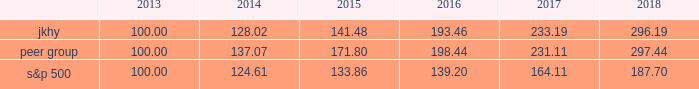14 2018 annual report performance graph the following chart presents a comparison for the five-year period ended june 30 , 2018 , of the market performance of the company 2019s common stock with the s&p 500 index and an index of peer companies selected by the company .
Historic stock price performance is not necessarily indicative of future stock price performance .
Comparison of 5 year cumulative total return among jack henry & associates , inc. , the s&p 500 index , and a peer group the following information depicts a line graph with the following values: .
This comparison assumes $ 100 was invested on june 30 , 2013 , and assumes reinvestments of dividends .
Total returns are calculated according to market capitalization of peer group members at the beginning of each period .
Peer companies selected are in the business of providing specialized computer software , hardware and related services to financial institutions and other businesses .
Companies in the peer group are aci worldwide , inc. ; bottomline technology , inc. ; broadridge financial solutions ; cardtronics , inc. ; convergys corp. ; corelogic , inc. ; euronet worldwide , inc. ; fair isaac corp. ; fidelity national information services , inc. ; fiserv , inc. ; global payments , inc. ; moneygram international , inc. ; ss&c technologies holdings , inc. ; total systems services , inc. ; tyler technologies , inc. ; verifone systems , inc. ; and wex , inc .
Dst systems , inc. , which had previously been part of the peer group , was acquired in 2018 and is no longer a public company .
As a result , dst systems , inc .
Has been removed from the peer group and stock performance graph .
The stock performance graph shall not be deemed 201cfiled 201d for purposes of section 18 of the exchange act , or incorporated by reference into any filing of the company under the securities act of 1933 , as amended , or the exchange act , except as shall be expressly set forth by specific reference in such filing. .
2 jkhy 100.00 128.02 141.48 193.46 233.19 296.19? 
Computations: (296.19 - 100.00)
Answer: 196.19. 